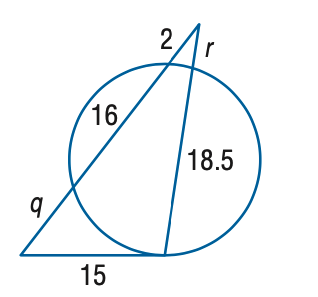Answer the mathemtical geometry problem and directly provide the correct option letter.
Question: Find the variable of r to the nearest tenth. Assume that segments that appear to be tangent are tangent.
Choices: A: 0.8 B: 1.8 C: 2.8 D: 3.8 B 